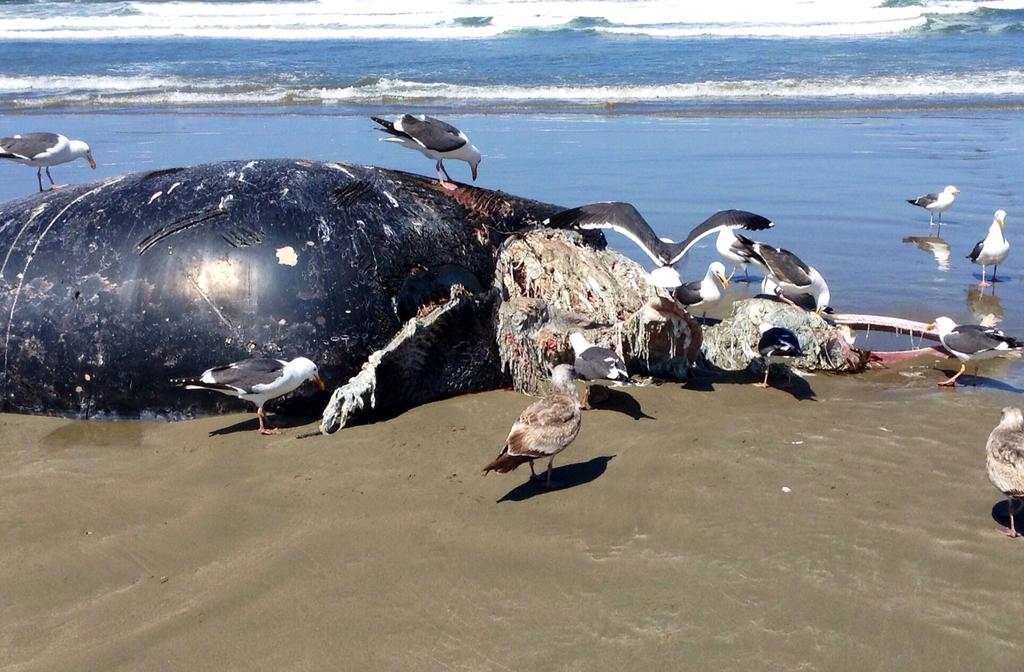What is the main subject of the image? There is a dead animal in the image. What other animals can be seen in the image? There are birds on the ground and two birds on the water in the image. What is visible in the background of the image? There is water visible in the background of the image. What song is the creator of the image listening to while creating the image? There is no information about the creator of the image or the song they might be listening to, so this cannot be answered definitively. 